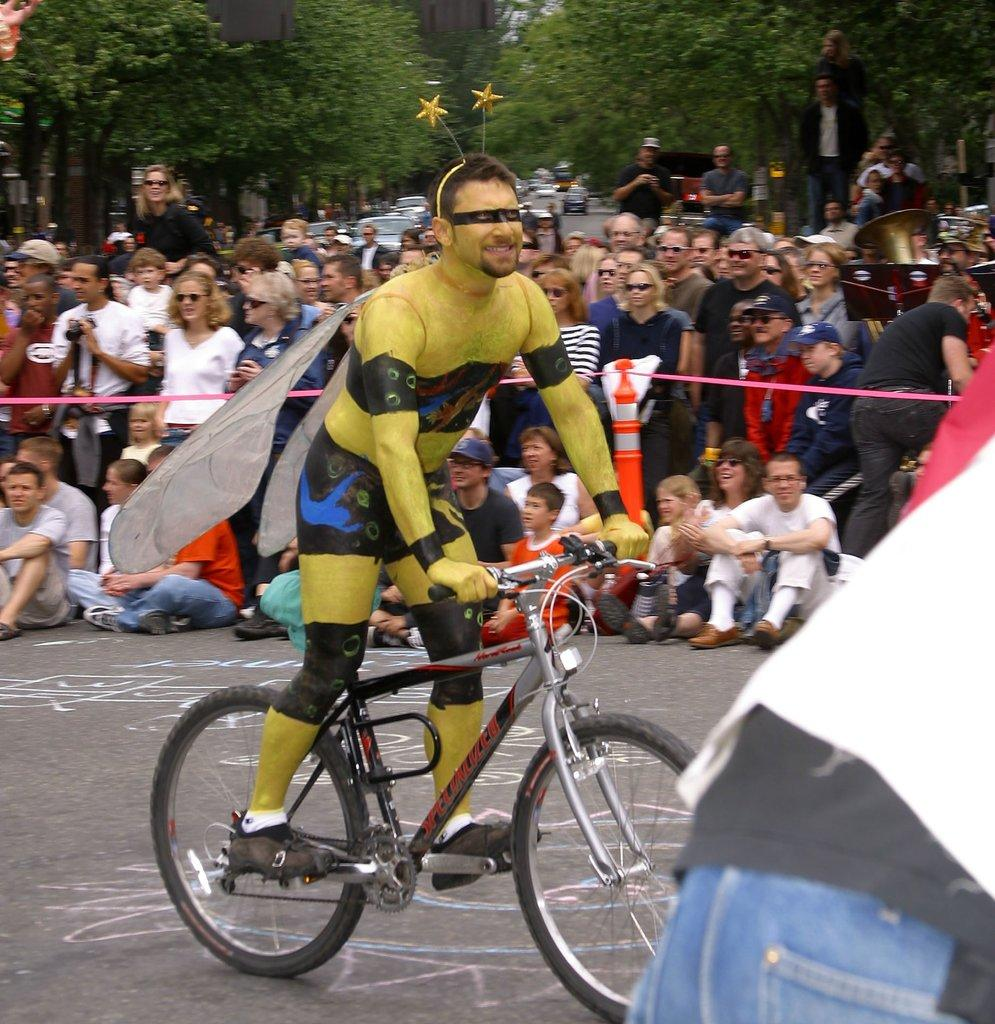What are the people in the image wearing? The persons in the image are wearing colorful clothes. What activity is one of the persons engaged in? There is a person riding a bicycle in the image. What type of vegetation can be seen in the image? There are trees visible in the image. What type of vehicles can be seen in the image? There are cars visible in the image. How many tomatoes are being held by the frog in the image? There is no frog or tomatoes present in the image. Are the girls in the image wearing matching outfits? There is no mention of girls in the image, only persons wearing colorful clothes. 